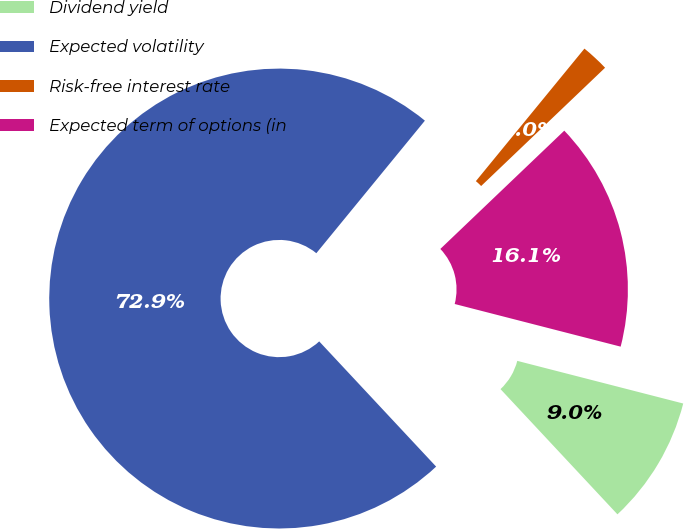Convert chart to OTSL. <chart><loc_0><loc_0><loc_500><loc_500><pie_chart><fcel>Dividend yield<fcel>Expected volatility<fcel>Risk-free interest rate<fcel>Expected term of options (in<nl><fcel>9.04%<fcel>72.87%<fcel>1.95%<fcel>16.13%<nl></chart> 